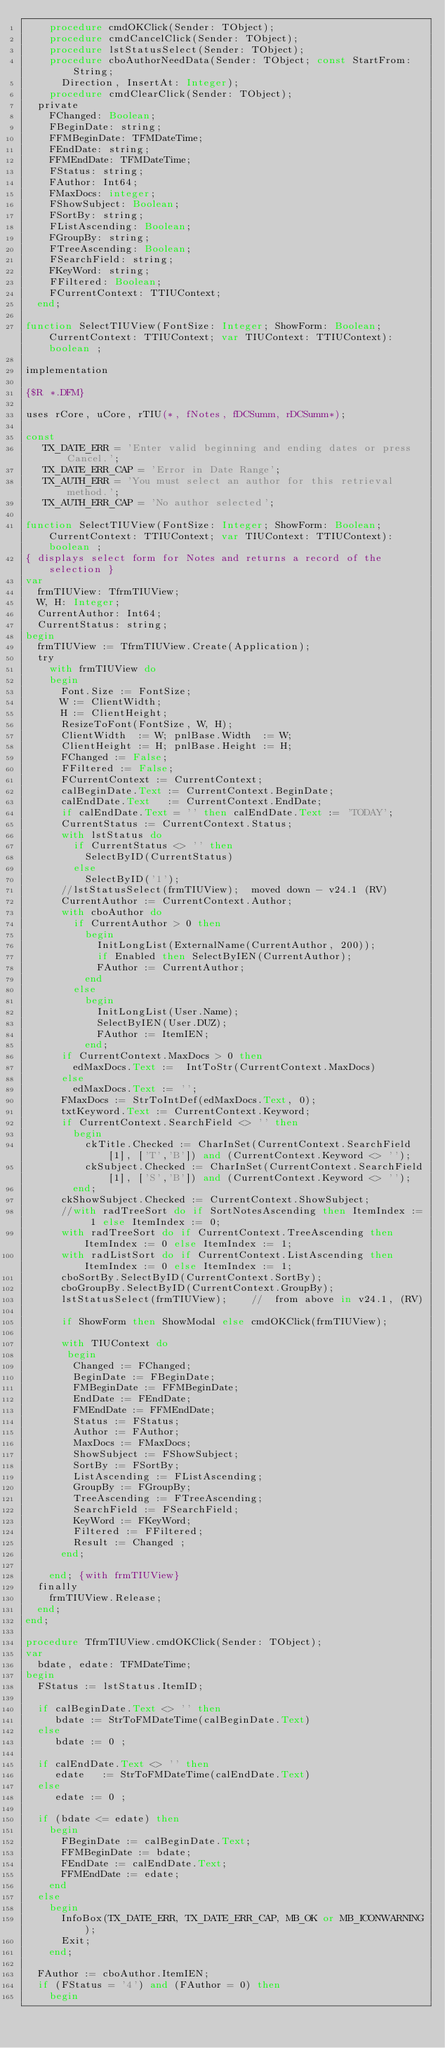Convert code to text. <code><loc_0><loc_0><loc_500><loc_500><_Pascal_>    procedure cmdOKClick(Sender: TObject);
    procedure cmdCancelClick(Sender: TObject);
    procedure lstStatusSelect(Sender: TObject);
    procedure cboAuthorNeedData(Sender: TObject; const StartFrom: String;
      Direction, InsertAt: Integer);
    procedure cmdClearClick(Sender: TObject);
  private
    FChanged: Boolean;
    FBeginDate: string;
    FFMBeginDate: TFMDateTime;
    FEndDate: string;
    FFMEndDate: TFMDateTime;
    FStatus: string;
    FAuthor: Int64;
    FMaxDocs: integer;
    FShowSubject: Boolean;
    FSortBy: string;
    FListAscending: Boolean;
    FGroupBy: string;
    FTreeAscending: Boolean;
    FSearchField: string;
    FKeyWord: string;
    FFiltered: Boolean;
    FCurrentContext: TTIUContext;
  end;

function SelectTIUView(FontSize: Integer; ShowForm: Boolean; CurrentContext: TTIUContext; var TIUContext: TTIUContext): boolean ;

implementation

{$R *.DFM}

uses rCore, uCore, rTIU(*, fNotes, fDCSumm, rDCSumm*);

const
   TX_DATE_ERR = 'Enter valid beginning and ending dates or press Cancel.';
   TX_DATE_ERR_CAP = 'Error in Date Range';
   TX_AUTH_ERR = 'You must select an author for this retrieval method.';
   TX_AUTH_ERR_CAP = 'No author selected';

function SelectTIUView(FontSize: Integer; ShowForm: Boolean; CurrentContext: TTIUContext; var TIUContext: TTIUContext): boolean ;
{ displays select form for Notes and returns a record of the selection }
var
  frmTIUView: TfrmTIUView;
  W, H: Integer;
  CurrentAuthor: Int64;
  CurrentStatus: string;
begin
  frmTIUView := TfrmTIUView.Create(Application);
  try
    with frmTIUView do
    begin
      Font.Size := FontSize;
      W := ClientWidth;
      H := ClientHeight;
      ResizeToFont(FontSize, W, H);
      ClientWidth  := W; pnlBase.Width  := W;
      ClientHeight := H; pnlBase.Height := H;
      FChanged := False;
      FFiltered := False;
      FCurrentContext := CurrentContext;
      calBeginDate.Text := CurrentContext.BeginDate;
      calEndDate.Text   := CurrentContext.EndDate;
      if calEndDate.Text = '' then calEndDate.Text := 'TODAY';
      CurrentStatus := CurrentContext.Status;
      with lstStatus do
        if CurrentStatus <> '' then
          SelectByID(CurrentStatus)
        else
          SelectByID('1');
      //lstStatusSelect(frmTIUView);  moved down - v24.1 (RV)
      CurrentAuthor := CurrentContext.Author;
      with cboAuthor do
        if CurrentAuthor > 0 then
          begin
            InitLongList(ExternalName(CurrentAuthor, 200));
            if Enabled then SelectByIEN(CurrentAuthor);
            FAuthor := CurrentAuthor;
          end
        else
          begin
            InitLongList(User.Name);
            SelectByIEN(User.DUZ);
            FAuthor := ItemIEN;
          end;
      if CurrentContext.MaxDocs > 0 then
        edMaxDocs.Text :=  IntToStr(CurrentContext.MaxDocs)
      else
        edMaxDocs.Text := '';
      FMaxDocs := StrToIntDef(edMaxDocs.Text, 0);
      txtKeyword.Text := CurrentContext.Keyword;
      if CurrentContext.SearchField <> '' then
        begin
          ckTitle.Checked := CharInSet(CurrentContext.SearchField[1], ['T','B']) and (CurrentContext.Keyword <> '');
          ckSubject.Checked := CharInSet(CurrentContext.SearchField[1], ['S','B']) and (CurrentContext.Keyword <> '');
        end;
      ckShowSubject.Checked := CurrentContext.ShowSubject;
      //with radTreeSort do if SortNotesAscending then ItemIndex := 1 else ItemIndex := 0;
      with radTreeSort do if CurrentContext.TreeAscending then ItemIndex := 0 else ItemIndex := 1;
      with radListSort do if CurrentContext.ListAscending then ItemIndex := 0 else ItemIndex := 1;
      cboSortBy.SelectByID(CurrentContext.SortBy);
      cboGroupBy.SelectByID(CurrentContext.GroupBy);
      lstStatusSelect(frmTIUView);    //  from above in v24.1, (RV)

      if ShowForm then ShowModal else cmdOKClick(frmTIUView);

      with TIUContext do
       begin
        Changed := FChanged;
        BeginDate := FBeginDate;
        FMBeginDate := FFMBeginDate;
        EndDate := FEndDate;
        FMEndDate := FFMEndDate;
        Status := FStatus;
        Author := FAuthor;
        MaxDocs := FMaxDocs;
        ShowSubject := FShowSubject;
        SortBy := FSortBy;
        ListAscending := FListAscending;
        GroupBy := FGroupBy;
        TreeAscending := FTreeAscending;
        SearchField := FSearchField;
        KeyWord := FKeyWord;
        Filtered := FFiltered;
        Result := Changed ;
      end;

    end; {with frmTIUView}
  finally
    frmTIUView.Release;
  end;
end;

procedure TfrmTIUView.cmdOKClick(Sender: TObject);
var
  bdate, edate: TFMDateTime;
begin
  FStatus := lstStatus.ItemID;

  if calBeginDate.Text <> '' then
     bdate := StrToFMDateTime(calBeginDate.Text)
  else
     bdate := 0 ;

  if calEndDate.Text <> '' then
     edate   := StrToFMDateTime(calEndDate.Text)
  else
     edate := 0 ;

  if (bdate <= edate) then
    begin
      FBeginDate := calBeginDate.Text;
      FFMBeginDate := bdate;
      FEndDate := calEndDate.Text;
      FFMEndDate := edate;
    end
  else
    begin
      InfoBox(TX_DATE_ERR, TX_DATE_ERR_CAP, MB_OK or MB_ICONWARNING);
      Exit;
    end;

  FAuthor := cboAuthor.ItemIEN;
  if (FStatus = '4') and (FAuthor = 0) then
    begin</code> 